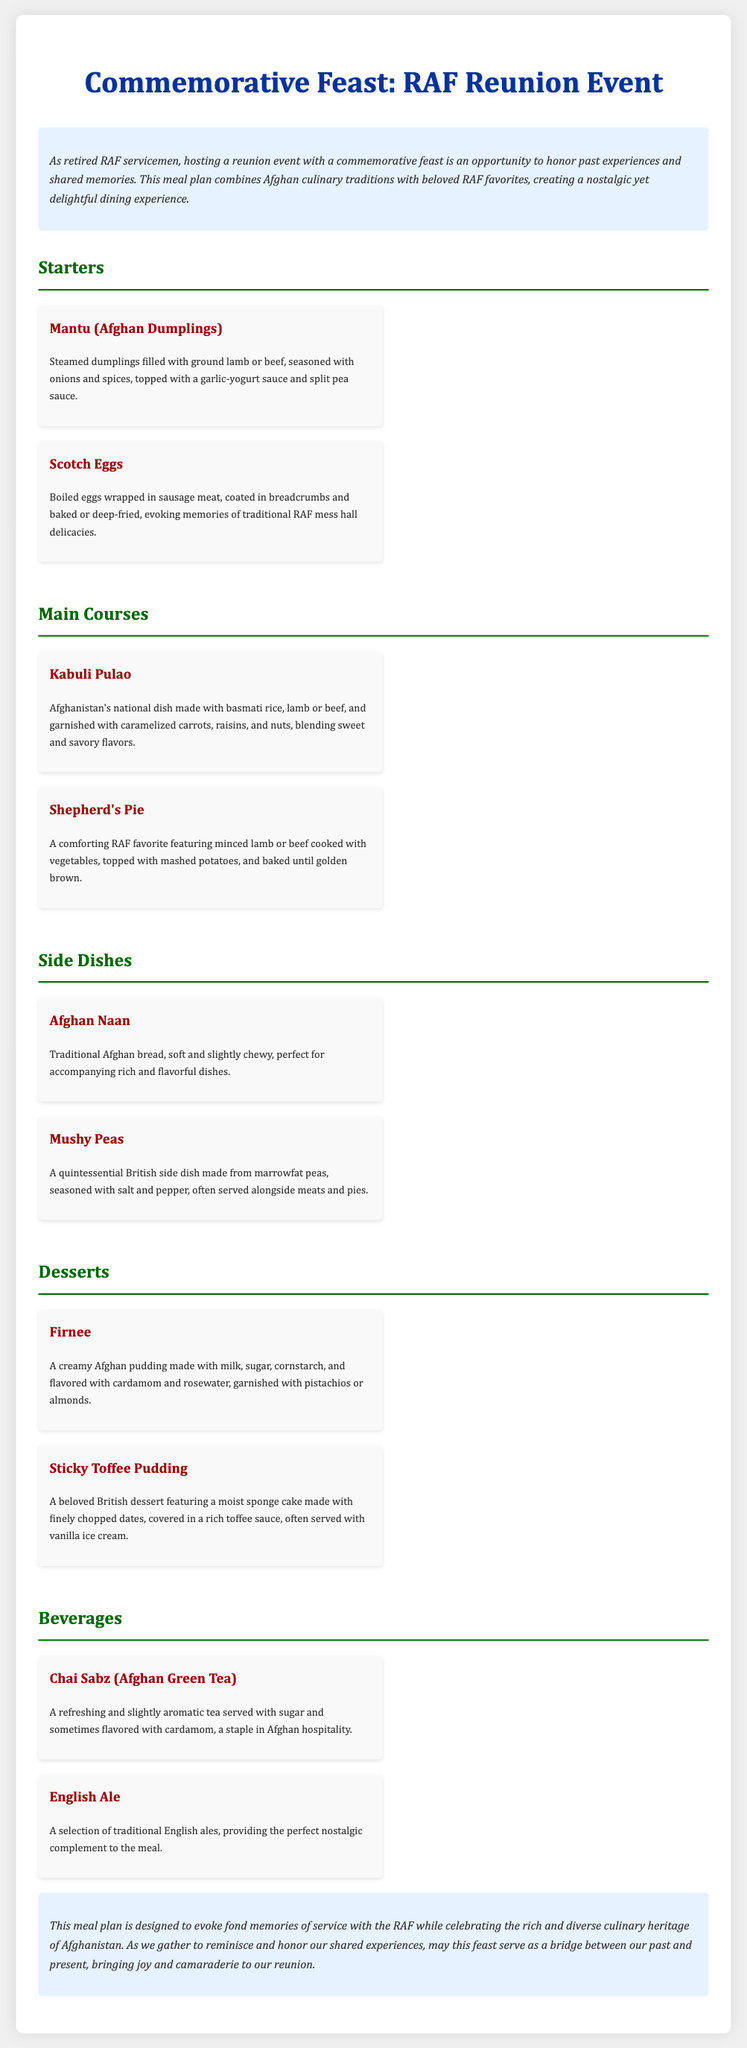What is the title of the document? The title of the document is provided in the header section, stating the theme of the meal plan.
Answer: Commemorative Feast: RAF Reunion Event How many types of starters are listed? The document provides a specific section for starters with two meal items listed under it.
Answer: 2 What is the main ingredient in Mantu? The description of Mantu explicitly mentions the filling used for these dumplings.
Answer: Ground lamb or beef What beverage is served with sugar and flavored with cardamom? The beverage section describes the Afghan green tea, highlighting this characteristic.
Answer: Chai Sabz Which dessert is a beloved British dessert? The dessert section clearly identifies Sticky Toffee Pudding as a British favorite.
Answer: Sticky Toffee Pudding What is Afghanistan's national dish mentioned in the document? The main course section specifically names this dish as a highlight from Afghan cuisine.
Answer: Kabuli Pulao Which side dish is made from marrowfat peas? The meal plan associated with side dishes clearly states the name of this traditional dish.
Answer: Mushy Peas What type of tea is included in the beverages section? The beverages section describes the different types of drinks, specifying the tea variety mentioned.
Answer: Afghan Green Tea 